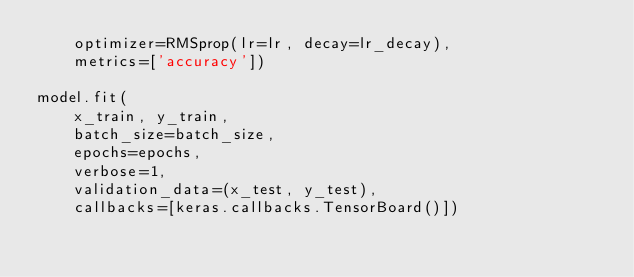<code> <loc_0><loc_0><loc_500><loc_500><_Python_>    optimizer=RMSprop(lr=lr, decay=lr_decay),
    metrics=['accuracy'])

model.fit(
    x_train, y_train,
    batch_size=batch_size,
    epochs=epochs,
    verbose=1,
    validation_data=(x_test, y_test),
    callbacks=[keras.callbacks.TensorBoard()])
</code> 